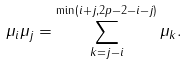Convert formula to latex. <formula><loc_0><loc_0><loc_500><loc_500>\mu _ { i } \mu _ { j } = \sum _ { k = j - i } ^ { \min ( i + j , 2 p - 2 - i - j ) } \mu _ { k } .</formula> 